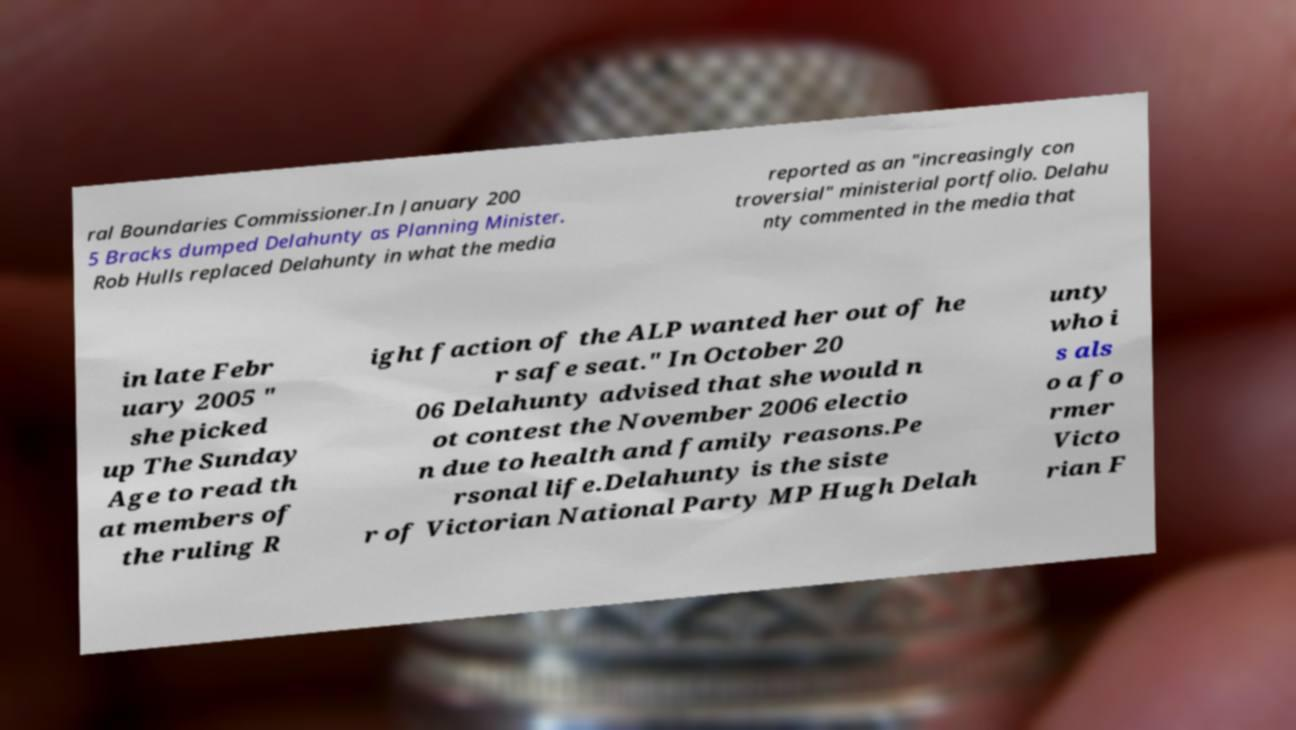Could you assist in decoding the text presented in this image and type it out clearly? ral Boundaries Commissioner.In January 200 5 Bracks dumped Delahunty as Planning Minister. Rob Hulls replaced Delahunty in what the media reported as an "increasingly con troversial" ministerial portfolio. Delahu nty commented in the media that in late Febr uary 2005 " she picked up The Sunday Age to read th at members of the ruling R ight faction of the ALP wanted her out of he r safe seat." In October 20 06 Delahunty advised that she would n ot contest the November 2006 electio n due to health and family reasons.Pe rsonal life.Delahunty is the siste r of Victorian National Party MP Hugh Delah unty who i s als o a fo rmer Victo rian F 